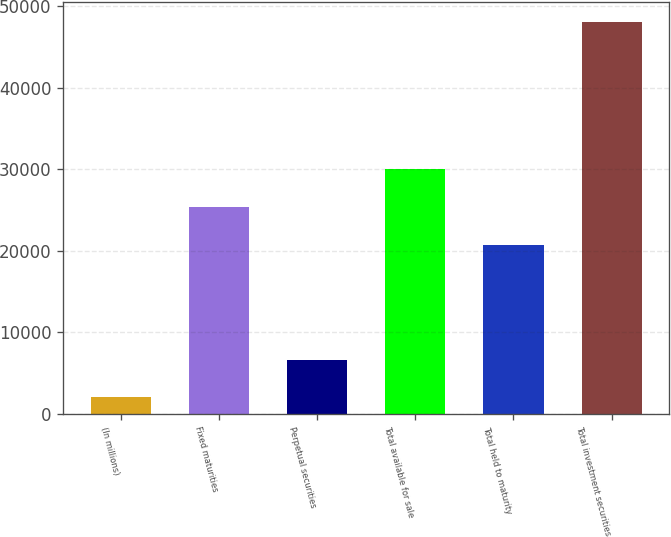<chart> <loc_0><loc_0><loc_500><loc_500><bar_chart><fcel>(In millions)<fcel>Fixed maturities<fcel>Perpetual securities<fcel>Total available for sale<fcel>Total held to maturity<fcel>Total investment securities<nl><fcel>2007<fcel>25393.5<fcel>6616.5<fcel>30003<fcel>20784<fcel>48102<nl></chart> 